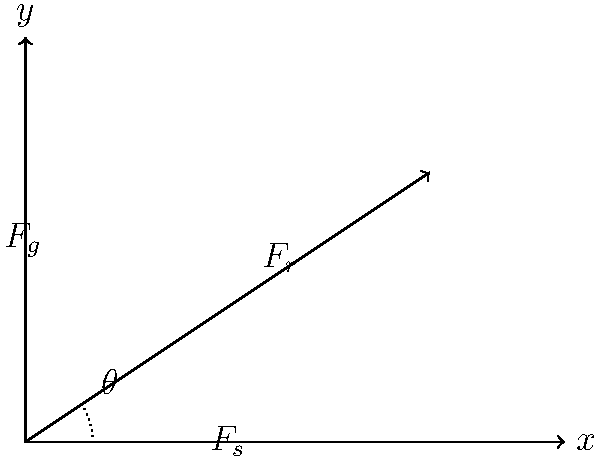In an automated seed planting mechanism for your genetically modified crop, the planting arm experiences three forces: gravity ($F_g$), soil resistance ($F_s$), and the robot's driving force ($F_r$). If $F_g = 50$ N, $F_s = 30$ N, and the angle $\theta$ between $F_s$ and the horizontal is $33.7°$, what magnitude of $F_r$ is required to keep the system in equilibrium? To solve this problem, we'll follow these steps:

1) First, we need to understand that for the system to be in equilibrium, the sum of forces in both x and y directions must be zero.

2) Let's break down the forces into their x and y components:

   $F_g$ is purely in the negative y direction: $(0, -50)$ N
   $F_s$ has components: $(F_s \cos \theta, F_s \sin \theta)$ N
   $F_r$ has unknown components: $(F_r \cos \phi, F_r \sin \phi)$ N, where $\phi$ is the unknown angle of $F_r$

3) Now, we can set up our equilibrium equations:

   x-direction: $F_s \cos \theta + F_r \cos \phi = 0$
   y-direction: $F_s \sin \theta + F_r \sin \phi - 50 = 0$

4) We know $F_s = 30$ N and $\theta = 33.7°$. Let's calculate the components of $F_s$:

   $F_s \cos \theta = 30 \cos 33.7° = 24.93$ N
   $F_s \sin \theta = 30 \sin 33.7° = 16.65$ N

5) Substituting these into our equations:

   $24.93 + F_r \cos \phi = 0$
   $16.65 + F_r \sin \phi - 50 = 0$

6) From the first equation: $F_r \cos \phi = -24.93$
   From the second equation: $F_r \sin \phi = 33.35$

7) To find $F_r$, we can square and add these equations:

   $(F_r \cos \phi)^2 + (F_r \sin \phi)^2 = (-24.93)^2 + (33.35)^2$

   $F_r^2 (\cos^2 \phi + \sin^2 \phi) = 621.5 + 1112.2 = 1733.7$

   $F_r^2 = 1733.7$ (since $\cos^2 \phi + \sin^2 \phi = 1$)

8) Taking the square root of both sides:

   $F_r = \sqrt{1733.7} = 41.64$ N

Therefore, the magnitude of $F_r$ required to keep the system in equilibrium is approximately 41.64 N.
Answer: 41.64 N 